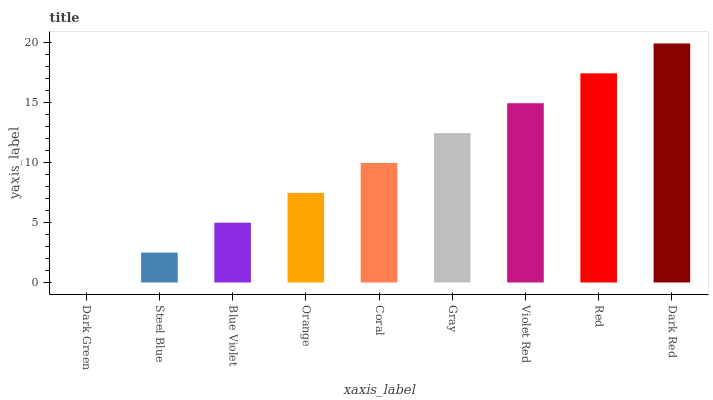Is Steel Blue the minimum?
Answer yes or no. No. Is Steel Blue the maximum?
Answer yes or no. No. Is Steel Blue greater than Dark Green?
Answer yes or no. Yes. Is Dark Green less than Steel Blue?
Answer yes or no. Yes. Is Dark Green greater than Steel Blue?
Answer yes or no. No. Is Steel Blue less than Dark Green?
Answer yes or no. No. Is Coral the high median?
Answer yes or no. Yes. Is Coral the low median?
Answer yes or no. Yes. Is Dark Green the high median?
Answer yes or no. No. Is Dark Green the low median?
Answer yes or no. No. 